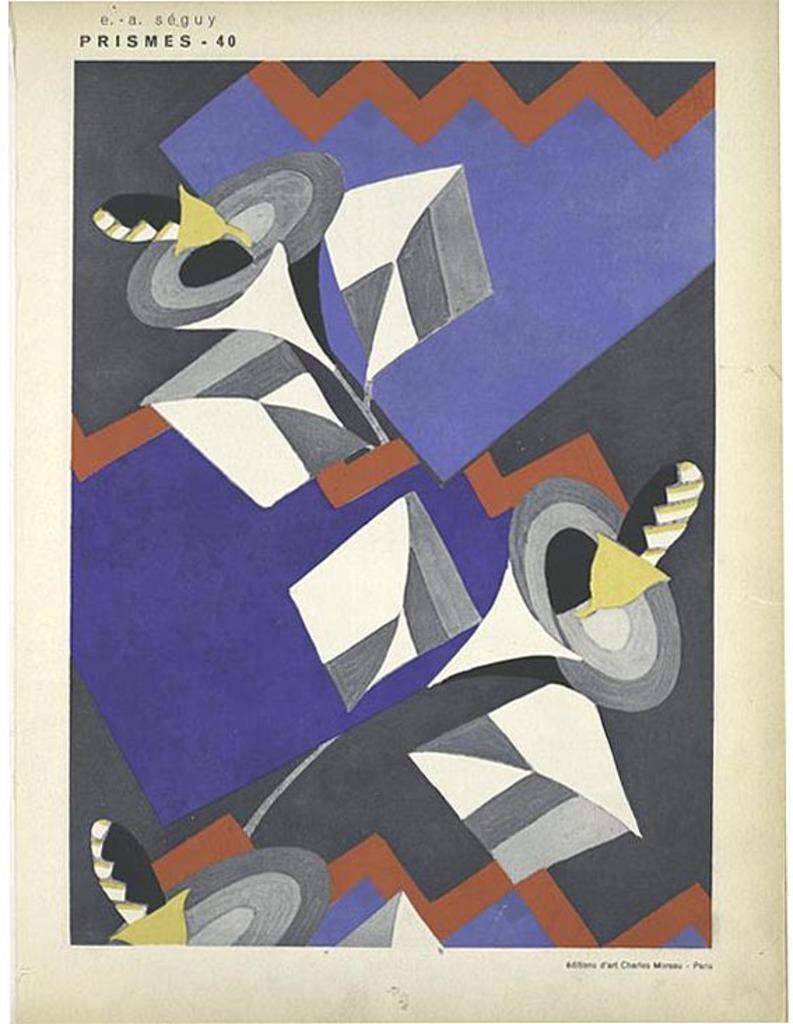How would you summarize this image in a sentence or two? In this image I can see an art. I can see colour of this art is blue, white, black, yellow and grey. I can also see something is written over here. 